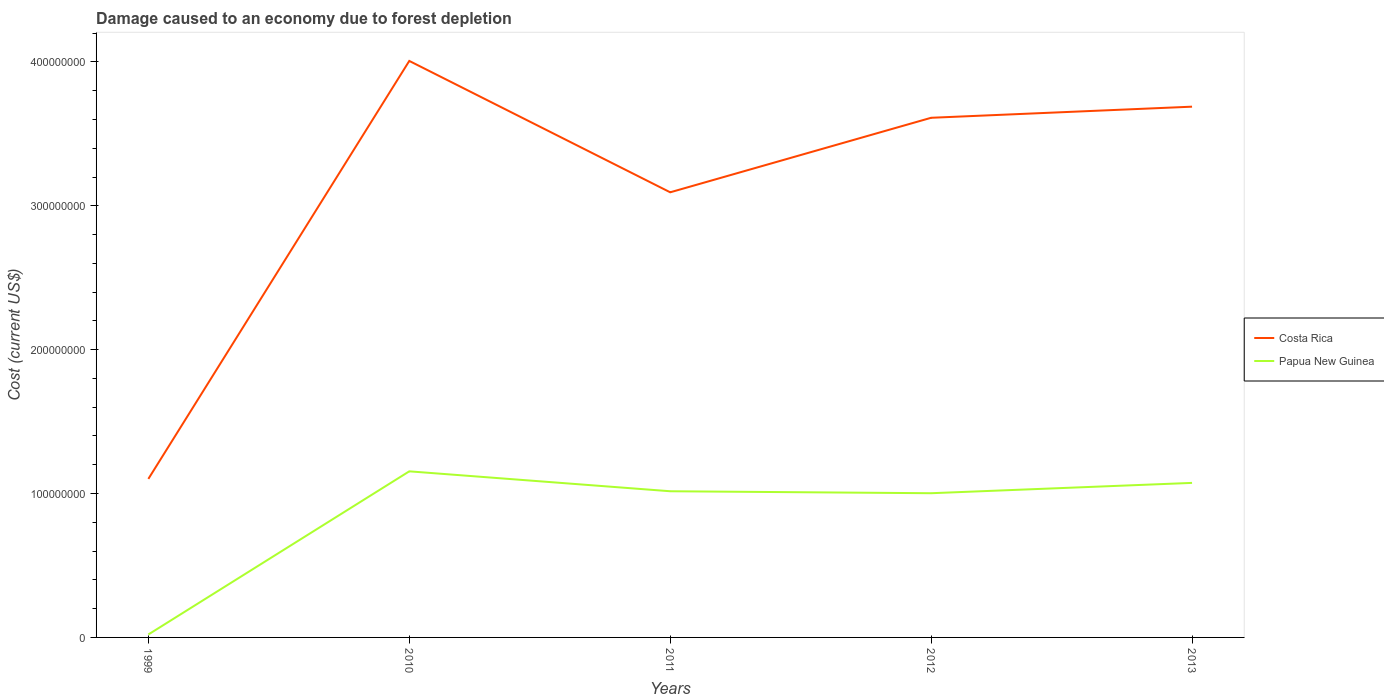How many different coloured lines are there?
Make the answer very short. 2. Does the line corresponding to Costa Rica intersect with the line corresponding to Papua New Guinea?
Your answer should be very brief. No. Across all years, what is the maximum cost of damage caused due to forest depletion in Papua New Guinea?
Make the answer very short. 2.04e+06. In which year was the cost of damage caused due to forest depletion in Costa Rica maximum?
Make the answer very short. 1999. What is the total cost of damage caused due to forest depletion in Costa Rica in the graph?
Give a very brief answer. 9.13e+07. What is the difference between the highest and the second highest cost of damage caused due to forest depletion in Papua New Guinea?
Your answer should be very brief. 1.13e+08. What is the difference between the highest and the lowest cost of damage caused due to forest depletion in Papua New Guinea?
Make the answer very short. 4. Is the cost of damage caused due to forest depletion in Costa Rica strictly greater than the cost of damage caused due to forest depletion in Papua New Guinea over the years?
Give a very brief answer. No. How many years are there in the graph?
Give a very brief answer. 5. Does the graph contain any zero values?
Offer a very short reply. No. Where does the legend appear in the graph?
Ensure brevity in your answer.  Center right. How many legend labels are there?
Give a very brief answer. 2. What is the title of the graph?
Offer a very short reply. Damage caused to an economy due to forest depletion. Does "Qatar" appear as one of the legend labels in the graph?
Your response must be concise. No. What is the label or title of the X-axis?
Give a very brief answer. Years. What is the label or title of the Y-axis?
Offer a very short reply. Cost (current US$). What is the Cost (current US$) in Costa Rica in 1999?
Your response must be concise. 1.10e+08. What is the Cost (current US$) in Papua New Guinea in 1999?
Provide a succinct answer. 2.04e+06. What is the Cost (current US$) in Costa Rica in 2010?
Provide a short and direct response. 4.01e+08. What is the Cost (current US$) in Papua New Guinea in 2010?
Your answer should be compact. 1.15e+08. What is the Cost (current US$) of Costa Rica in 2011?
Offer a terse response. 3.09e+08. What is the Cost (current US$) in Papua New Guinea in 2011?
Your response must be concise. 1.02e+08. What is the Cost (current US$) in Costa Rica in 2012?
Your response must be concise. 3.61e+08. What is the Cost (current US$) in Papua New Guinea in 2012?
Offer a very short reply. 1.00e+08. What is the Cost (current US$) in Costa Rica in 2013?
Provide a succinct answer. 3.69e+08. What is the Cost (current US$) of Papua New Guinea in 2013?
Ensure brevity in your answer.  1.07e+08. Across all years, what is the maximum Cost (current US$) of Costa Rica?
Your response must be concise. 4.01e+08. Across all years, what is the maximum Cost (current US$) in Papua New Guinea?
Your answer should be very brief. 1.15e+08. Across all years, what is the minimum Cost (current US$) in Costa Rica?
Keep it short and to the point. 1.10e+08. Across all years, what is the minimum Cost (current US$) of Papua New Guinea?
Ensure brevity in your answer.  2.04e+06. What is the total Cost (current US$) of Costa Rica in the graph?
Your response must be concise. 1.55e+09. What is the total Cost (current US$) in Papua New Guinea in the graph?
Give a very brief answer. 4.27e+08. What is the difference between the Cost (current US$) in Costa Rica in 1999 and that in 2010?
Offer a terse response. -2.91e+08. What is the difference between the Cost (current US$) in Papua New Guinea in 1999 and that in 2010?
Make the answer very short. -1.13e+08. What is the difference between the Cost (current US$) in Costa Rica in 1999 and that in 2011?
Make the answer very short. -1.99e+08. What is the difference between the Cost (current US$) in Papua New Guinea in 1999 and that in 2011?
Your response must be concise. -9.96e+07. What is the difference between the Cost (current US$) of Costa Rica in 1999 and that in 2012?
Give a very brief answer. -2.51e+08. What is the difference between the Cost (current US$) in Papua New Guinea in 1999 and that in 2012?
Your answer should be compact. -9.82e+07. What is the difference between the Cost (current US$) in Costa Rica in 1999 and that in 2013?
Give a very brief answer. -2.59e+08. What is the difference between the Cost (current US$) of Papua New Guinea in 1999 and that in 2013?
Keep it short and to the point. -1.05e+08. What is the difference between the Cost (current US$) in Costa Rica in 2010 and that in 2011?
Offer a very short reply. 9.13e+07. What is the difference between the Cost (current US$) in Papua New Guinea in 2010 and that in 2011?
Offer a terse response. 1.38e+07. What is the difference between the Cost (current US$) of Costa Rica in 2010 and that in 2012?
Offer a very short reply. 3.95e+07. What is the difference between the Cost (current US$) in Papua New Guinea in 2010 and that in 2012?
Your answer should be compact. 1.52e+07. What is the difference between the Cost (current US$) in Costa Rica in 2010 and that in 2013?
Provide a succinct answer. 3.18e+07. What is the difference between the Cost (current US$) of Papua New Guinea in 2010 and that in 2013?
Your answer should be compact. 8.03e+06. What is the difference between the Cost (current US$) of Costa Rica in 2011 and that in 2012?
Keep it short and to the point. -5.18e+07. What is the difference between the Cost (current US$) in Papua New Guinea in 2011 and that in 2012?
Give a very brief answer. 1.37e+06. What is the difference between the Cost (current US$) of Costa Rica in 2011 and that in 2013?
Keep it short and to the point. -5.95e+07. What is the difference between the Cost (current US$) in Papua New Guinea in 2011 and that in 2013?
Offer a terse response. -5.81e+06. What is the difference between the Cost (current US$) in Costa Rica in 2012 and that in 2013?
Provide a succinct answer. -7.72e+06. What is the difference between the Cost (current US$) in Papua New Guinea in 2012 and that in 2013?
Ensure brevity in your answer.  -7.18e+06. What is the difference between the Cost (current US$) in Costa Rica in 1999 and the Cost (current US$) in Papua New Guinea in 2010?
Offer a very short reply. -5.26e+06. What is the difference between the Cost (current US$) in Costa Rica in 1999 and the Cost (current US$) in Papua New Guinea in 2011?
Your response must be concise. 8.58e+06. What is the difference between the Cost (current US$) in Costa Rica in 1999 and the Cost (current US$) in Papua New Guinea in 2012?
Ensure brevity in your answer.  9.95e+06. What is the difference between the Cost (current US$) of Costa Rica in 1999 and the Cost (current US$) of Papua New Guinea in 2013?
Make the answer very short. 2.77e+06. What is the difference between the Cost (current US$) in Costa Rica in 2010 and the Cost (current US$) in Papua New Guinea in 2011?
Keep it short and to the point. 2.99e+08. What is the difference between the Cost (current US$) of Costa Rica in 2010 and the Cost (current US$) of Papua New Guinea in 2012?
Ensure brevity in your answer.  3.00e+08. What is the difference between the Cost (current US$) of Costa Rica in 2010 and the Cost (current US$) of Papua New Guinea in 2013?
Ensure brevity in your answer.  2.93e+08. What is the difference between the Cost (current US$) in Costa Rica in 2011 and the Cost (current US$) in Papua New Guinea in 2012?
Make the answer very short. 2.09e+08. What is the difference between the Cost (current US$) of Costa Rica in 2011 and the Cost (current US$) of Papua New Guinea in 2013?
Your answer should be very brief. 2.02e+08. What is the difference between the Cost (current US$) of Costa Rica in 2012 and the Cost (current US$) of Papua New Guinea in 2013?
Give a very brief answer. 2.54e+08. What is the average Cost (current US$) in Costa Rica per year?
Provide a short and direct response. 3.10e+08. What is the average Cost (current US$) of Papua New Guinea per year?
Provide a succinct answer. 8.53e+07. In the year 1999, what is the difference between the Cost (current US$) of Costa Rica and Cost (current US$) of Papua New Guinea?
Offer a very short reply. 1.08e+08. In the year 2010, what is the difference between the Cost (current US$) of Costa Rica and Cost (current US$) of Papua New Guinea?
Give a very brief answer. 2.85e+08. In the year 2011, what is the difference between the Cost (current US$) in Costa Rica and Cost (current US$) in Papua New Guinea?
Offer a terse response. 2.08e+08. In the year 2012, what is the difference between the Cost (current US$) in Costa Rica and Cost (current US$) in Papua New Guinea?
Offer a terse response. 2.61e+08. In the year 2013, what is the difference between the Cost (current US$) of Costa Rica and Cost (current US$) of Papua New Guinea?
Provide a short and direct response. 2.61e+08. What is the ratio of the Cost (current US$) in Costa Rica in 1999 to that in 2010?
Provide a short and direct response. 0.28. What is the ratio of the Cost (current US$) in Papua New Guinea in 1999 to that in 2010?
Your answer should be compact. 0.02. What is the ratio of the Cost (current US$) of Costa Rica in 1999 to that in 2011?
Provide a succinct answer. 0.36. What is the ratio of the Cost (current US$) in Papua New Guinea in 1999 to that in 2011?
Your response must be concise. 0.02. What is the ratio of the Cost (current US$) of Costa Rica in 1999 to that in 2012?
Your answer should be very brief. 0.31. What is the ratio of the Cost (current US$) of Papua New Guinea in 1999 to that in 2012?
Offer a very short reply. 0.02. What is the ratio of the Cost (current US$) of Costa Rica in 1999 to that in 2013?
Your answer should be compact. 0.3. What is the ratio of the Cost (current US$) in Papua New Guinea in 1999 to that in 2013?
Keep it short and to the point. 0.02. What is the ratio of the Cost (current US$) in Costa Rica in 2010 to that in 2011?
Provide a succinct answer. 1.3. What is the ratio of the Cost (current US$) of Papua New Guinea in 2010 to that in 2011?
Keep it short and to the point. 1.14. What is the ratio of the Cost (current US$) of Costa Rica in 2010 to that in 2012?
Make the answer very short. 1.11. What is the ratio of the Cost (current US$) of Papua New Guinea in 2010 to that in 2012?
Ensure brevity in your answer.  1.15. What is the ratio of the Cost (current US$) of Costa Rica in 2010 to that in 2013?
Ensure brevity in your answer.  1.09. What is the ratio of the Cost (current US$) of Papua New Guinea in 2010 to that in 2013?
Your response must be concise. 1.07. What is the ratio of the Cost (current US$) of Costa Rica in 2011 to that in 2012?
Offer a terse response. 0.86. What is the ratio of the Cost (current US$) of Papua New Guinea in 2011 to that in 2012?
Your response must be concise. 1.01. What is the ratio of the Cost (current US$) in Costa Rica in 2011 to that in 2013?
Your answer should be compact. 0.84. What is the ratio of the Cost (current US$) of Papua New Guinea in 2011 to that in 2013?
Offer a very short reply. 0.95. What is the ratio of the Cost (current US$) in Costa Rica in 2012 to that in 2013?
Provide a succinct answer. 0.98. What is the ratio of the Cost (current US$) in Papua New Guinea in 2012 to that in 2013?
Your answer should be compact. 0.93. What is the difference between the highest and the second highest Cost (current US$) in Costa Rica?
Offer a very short reply. 3.18e+07. What is the difference between the highest and the second highest Cost (current US$) of Papua New Guinea?
Offer a terse response. 8.03e+06. What is the difference between the highest and the lowest Cost (current US$) in Costa Rica?
Offer a terse response. 2.91e+08. What is the difference between the highest and the lowest Cost (current US$) in Papua New Guinea?
Keep it short and to the point. 1.13e+08. 